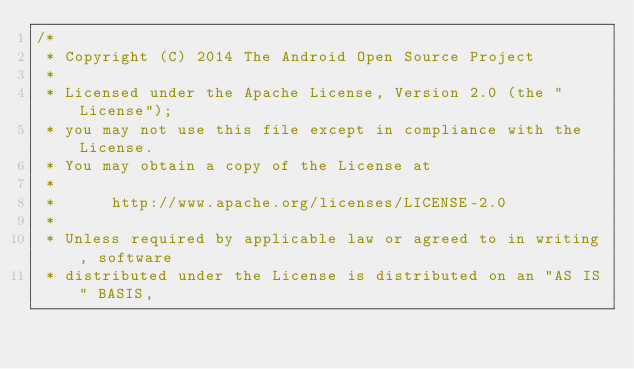Convert code to text. <code><loc_0><loc_0><loc_500><loc_500><_Java_>/*
 * Copyright (C) 2014 The Android Open Source Project
 *
 * Licensed under the Apache License, Version 2.0 (the "License");
 * you may not use this file except in compliance with the License.
 * You may obtain a copy of the License at
 *
 *      http://www.apache.org/licenses/LICENSE-2.0
 *
 * Unless required by applicable law or agreed to in writing, software
 * distributed under the License is distributed on an "AS IS" BASIS,</code> 